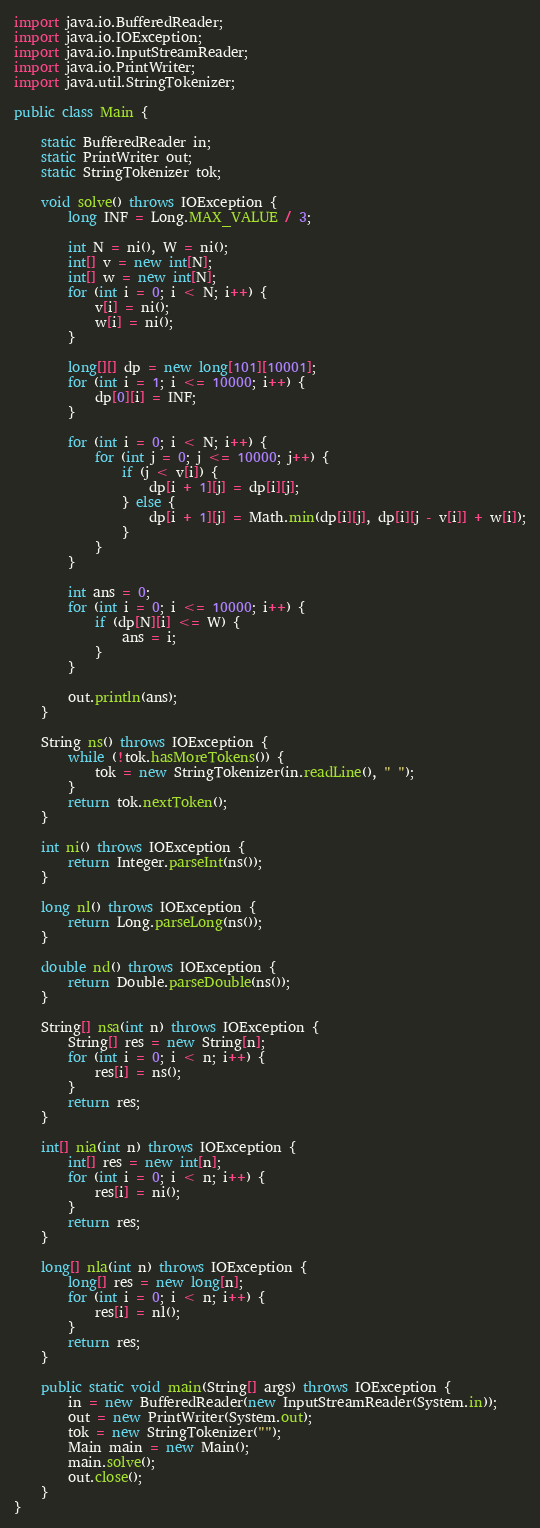<code> <loc_0><loc_0><loc_500><loc_500><_Java_>import java.io.BufferedReader;
import java.io.IOException;
import java.io.InputStreamReader;
import java.io.PrintWriter;
import java.util.StringTokenizer;

public class Main {

    static BufferedReader in;
    static PrintWriter out;
    static StringTokenizer tok;

    void solve() throws IOException {
        long INF = Long.MAX_VALUE / 3;

        int N = ni(), W = ni();
        int[] v = new int[N];
        int[] w = new int[N];
        for (int i = 0; i < N; i++) {
            v[i] = ni();
            w[i] = ni();
        }

        long[][] dp = new long[101][10001];
        for (int i = 1; i <= 10000; i++) {
            dp[0][i] = INF;
        }

        for (int i = 0; i < N; i++) {
            for (int j = 0; j <= 10000; j++) {
                if (j < v[i]) {
                    dp[i + 1][j] = dp[i][j];
                } else {
                    dp[i + 1][j] = Math.min(dp[i][j], dp[i][j - v[i]] + w[i]);
                }
            }
        }

        int ans = 0;
        for (int i = 0; i <= 10000; i++) {
            if (dp[N][i] <= W) {
                ans = i;
            }
        }

        out.println(ans);
    }

    String ns() throws IOException {
        while (!tok.hasMoreTokens()) {
            tok = new StringTokenizer(in.readLine(), " ");
        }
        return tok.nextToken();
    }

    int ni() throws IOException {
        return Integer.parseInt(ns());
    }

    long nl() throws IOException {
        return Long.parseLong(ns());
    }

    double nd() throws IOException {
        return Double.parseDouble(ns());
    }

    String[] nsa(int n) throws IOException {
        String[] res = new String[n];
        for (int i = 0; i < n; i++) {
            res[i] = ns();
        }
        return res;
    }

    int[] nia(int n) throws IOException {
        int[] res = new int[n];
        for (int i = 0; i < n; i++) {
            res[i] = ni();
        }
        return res;
    }

    long[] nla(int n) throws IOException {
        long[] res = new long[n];
        for (int i = 0; i < n; i++) {
            res[i] = nl();
        }
        return res;
    }

    public static void main(String[] args) throws IOException {
        in = new BufferedReader(new InputStreamReader(System.in));
        out = new PrintWriter(System.out);
        tok = new StringTokenizer("");
        Main main = new Main();
        main.solve();
        out.close();
    }
}</code> 